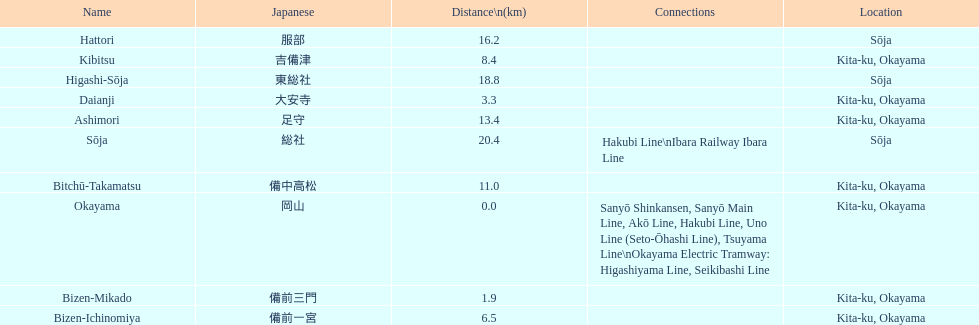Name only the stations that have connections to other lines. Okayama, Sōja. 